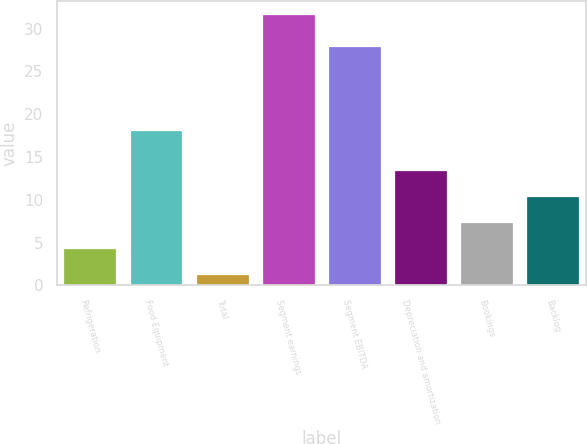<chart> <loc_0><loc_0><loc_500><loc_500><bar_chart><fcel>Refrigeration<fcel>Food Equipment<fcel>Total<fcel>Segment earnings<fcel>Segment EBITDA<fcel>Depreciation and amortization<fcel>Bookings<fcel>Backlog<nl><fcel>4.34<fcel>18.2<fcel>1.3<fcel>31.7<fcel>28<fcel>13.46<fcel>7.38<fcel>10.42<nl></chart> 